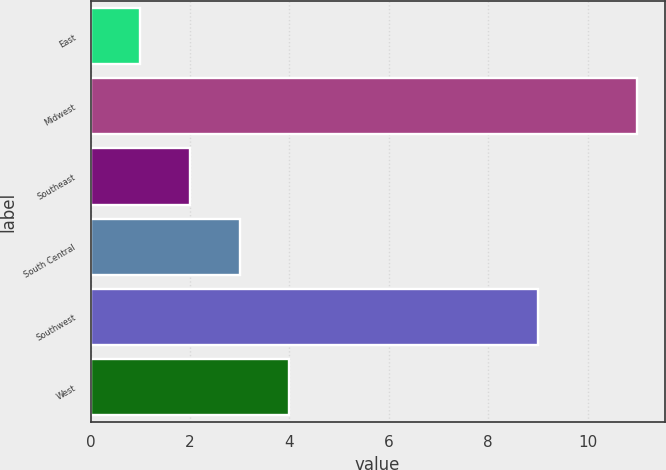<chart> <loc_0><loc_0><loc_500><loc_500><bar_chart><fcel>East<fcel>Midwest<fcel>Southeast<fcel>South Central<fcel>Southwest<fcel>West<nl><fcel>1<fcel>11<fcel>2<fcel>3<fcel>9<fcel>4<nl></chart> 